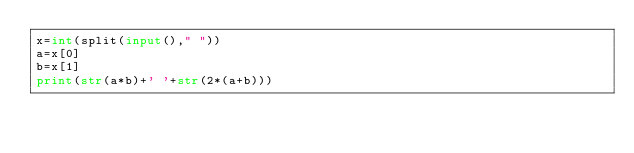Convert code to text. <code><loc_0><loc_0><loc_500><loc_500><_Python_>x=int(split(input()," "))
a=x[0]
b=x[1]
print(str(a*b)+' '+str(2*(a+b)))</code> 